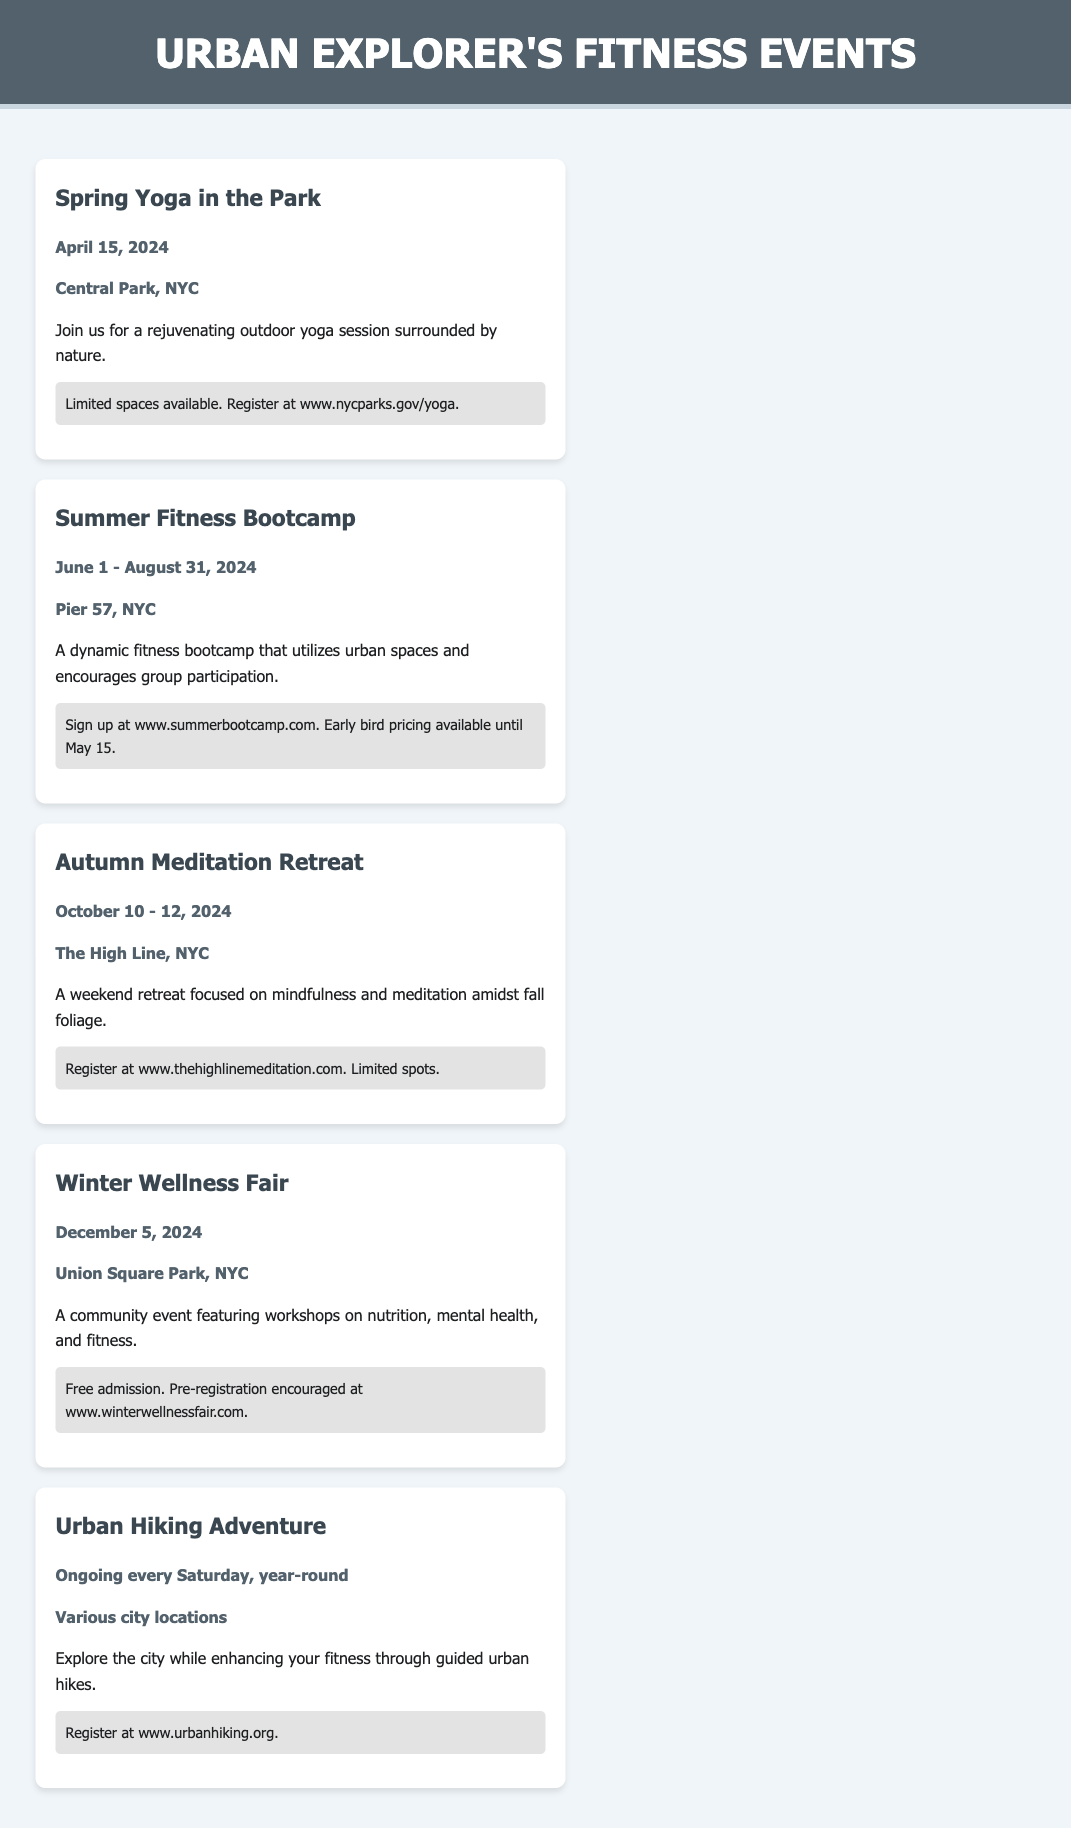what is the date of the Spring Yoga in the Park event? The date can be found in the event details section for Spring Yoga in the Park.
Answer: April 15, 2024 where is the Summer Fitness Bootcamp taking place? The location is specified in the event details for the Summer Fitness Bootcamp.
Answer: Pier 57, NYC how long does the Autumn Meditation Retreat last? The duration is indicated in the event details for the Autumn Meditation Retreat.
Answer: October 10 - 12, 2024 what type of event is scheduled for December 5, 2024? The type of event is mentioned in the description for the Winter Wellness Fair.
Answer: Community event when does the Urban Hiking Adventure occur? The schedule for the Urban Hiking Adventure is given in the event details section.
Answer: Ongoing every Saturday, year-round which event has registration encouraged but not required? Based on the registration details, the event that mentions this is identified.
Answer: Winter Wellness Fair what is the registration website for the Spring Yoga in the Park? The registration details will provide the website link for the Spring Yoga event.
Answer: www.nycparks.gov/yoga how many events are held in the summer? The document can be scanned to count summer events listed.
Answer: 1 